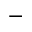Convert formula to latex. <formula><loc_0><loc_0><loc_500><loc_500>^ { - }</formula> 